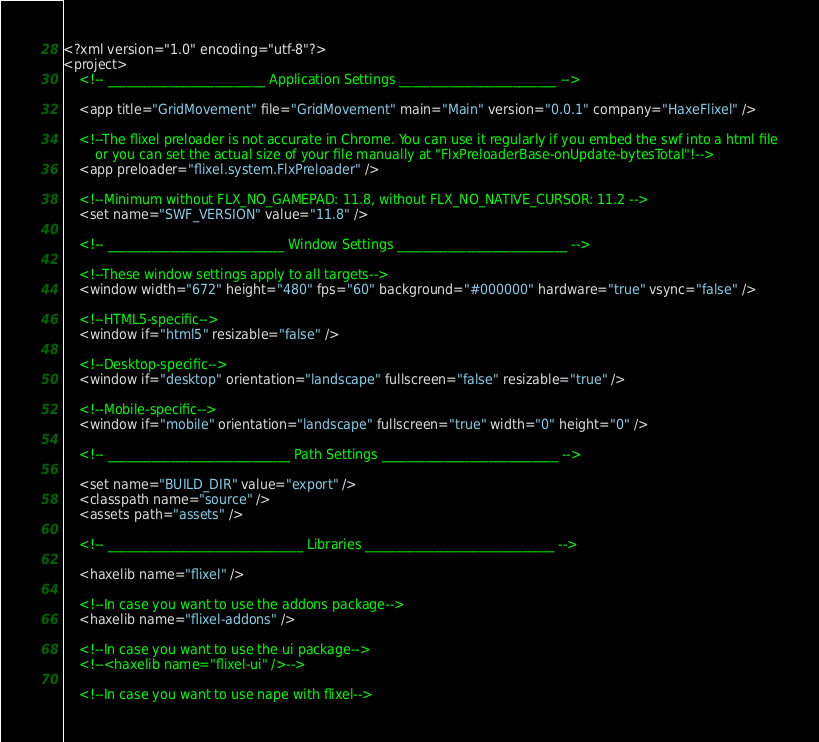<code> <loc_0><loc_0><loc_500><loc_500><_XML_><?xml version="1.0" encoding="utf-8"?>
<project>
	<!-- _________________________ Application Settings _________________________ -->
	
	<app title="GridMovement" file="GridMovement" main="Main" version="0.0.1" company="HaxeFlixel" />
	
	<!--The flixel preloader is not accurate in Chrome. You can use it regularly if you embed the swf into a html file
		or you can set the actual size of your file manually at "FlxPreloaderBase-onUpdate-bytesTotal"!-->
	<app preloader="flixel.system.FlxPreloader" />
	
	<!--Minimum without FLX_NO_GAMEPAD: 11.8, without FLX_NO_NATIVE_CURSOR: 11.2 -->
	<set name="SWF_VERSION" value="11.8" />
	
	<!-- ____________________________ Window Settings ___________________________ -->
	
	<!--These window settings apply to all targets-->
	<window width="672" height="480" fps="60" background="#000000" hardware="true" vsync="false" />
	
	<!--HTML5-specific-->
	<window if="html5" resizable="false" />
	
	<!--Desktop-specific-->
	<window if="desktop" orientation="landscape" fullscreen="false" resizable="true" />
	
	<!--Mobile-specific-->
	<window if="mobile" orientation="landscape" fullscreen="true" width="0" height="0" />
	
	<!-- _____________________________ Path Settings ____________________________ -->
	
	<set name="BUILD_DIR" value="export" />
	<classpath name="source" />
	<assets path="assets" />
	
	<!-- _______________________________ Libraries ______________________________ -->

	<haxelib name="flixel" />
	
	<!--In case you want to use the addons package-->
	<haxelib name="flixel-addons" />
	
	<!--In case you want to use the ui package-->
	<!--<haxelib name="flixel-ui" />-->
	
	<!--In case you want to use nape with flixel--></code> 